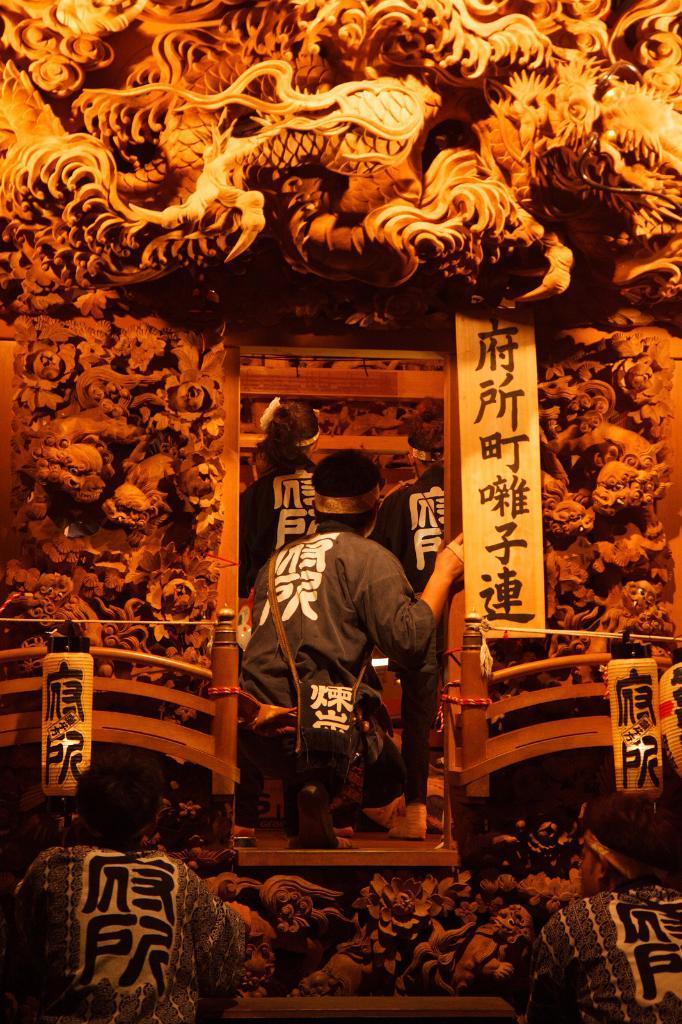What is the position of the person in the image? There is a person bent on his knees in the image. What can be seen in the background of the image? There are two other people in a cave-like structure in front of the person on his knees. Are there any other people visible in the image? Yes, there are two other people in front of the image. What type of crack is visible on the person's knee in the image? There is no crack visible on the person's knee in the image. How much money is being exchanged between the people in the image? There is no mention of money or any exchange in the image. 